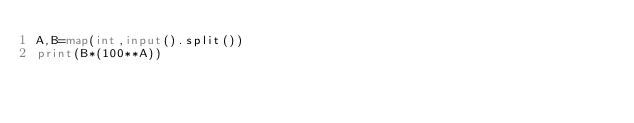<code> <loc_0><loc_0><loc_500><loc_500><_Python_>A,B=map(int,input().split())
print(B*(100**A))</code> 